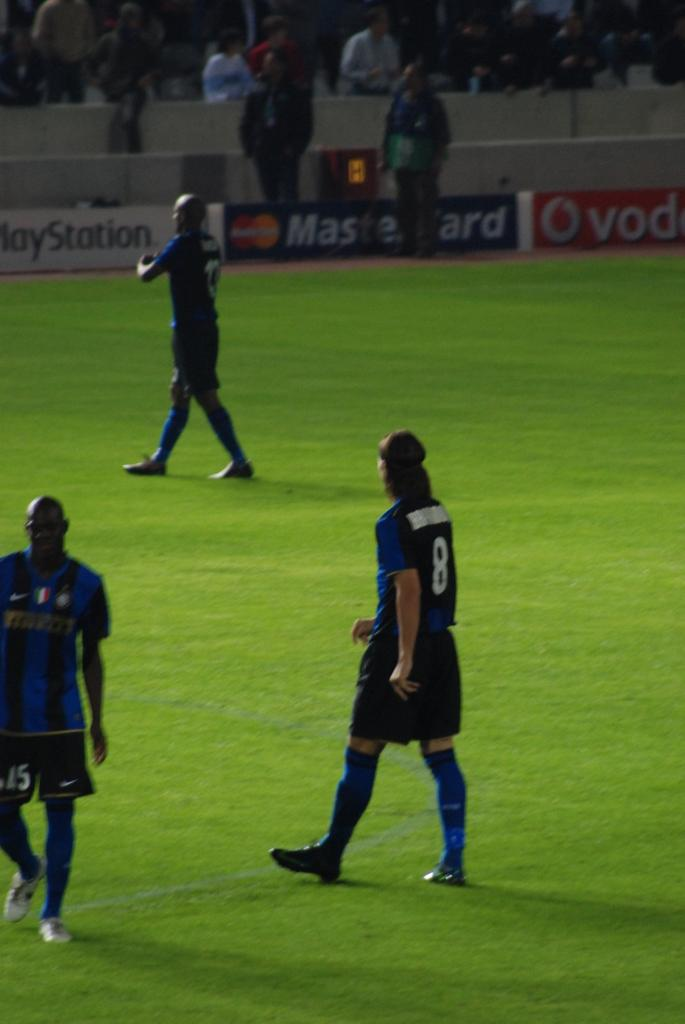<image>
Summarize the visual content of the image. Soccer players on a field that is sponsored by Mastercard 